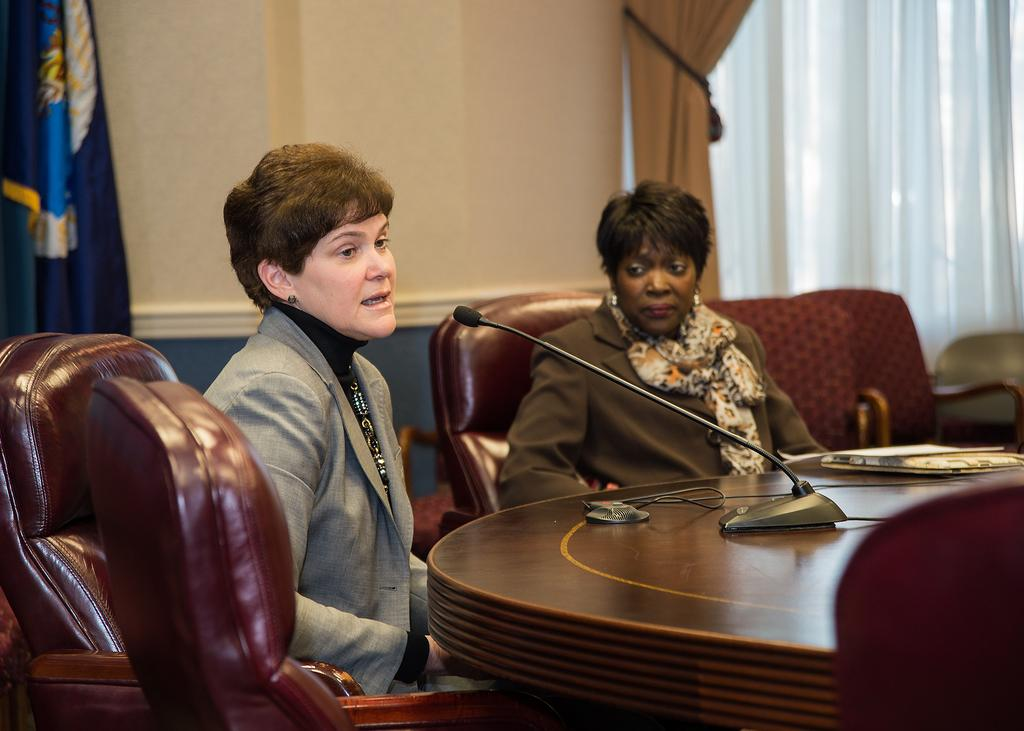How many people are in the image? There are two people in the image. What are the people doing in the image? The people are sitting on a sofa. What is located in front of the sofa? There is a table in front of the sofa. What object is on the table? A mic is present on the table. What can be seen outside the window in the image? The facts provided do not mention what can be seen outside the window. What type of knife is being used to cut the cake at the party in the image? There is no cake or party present in the image. What organization is hosting the event in the image? There is no event or organization mentioned in the image. 